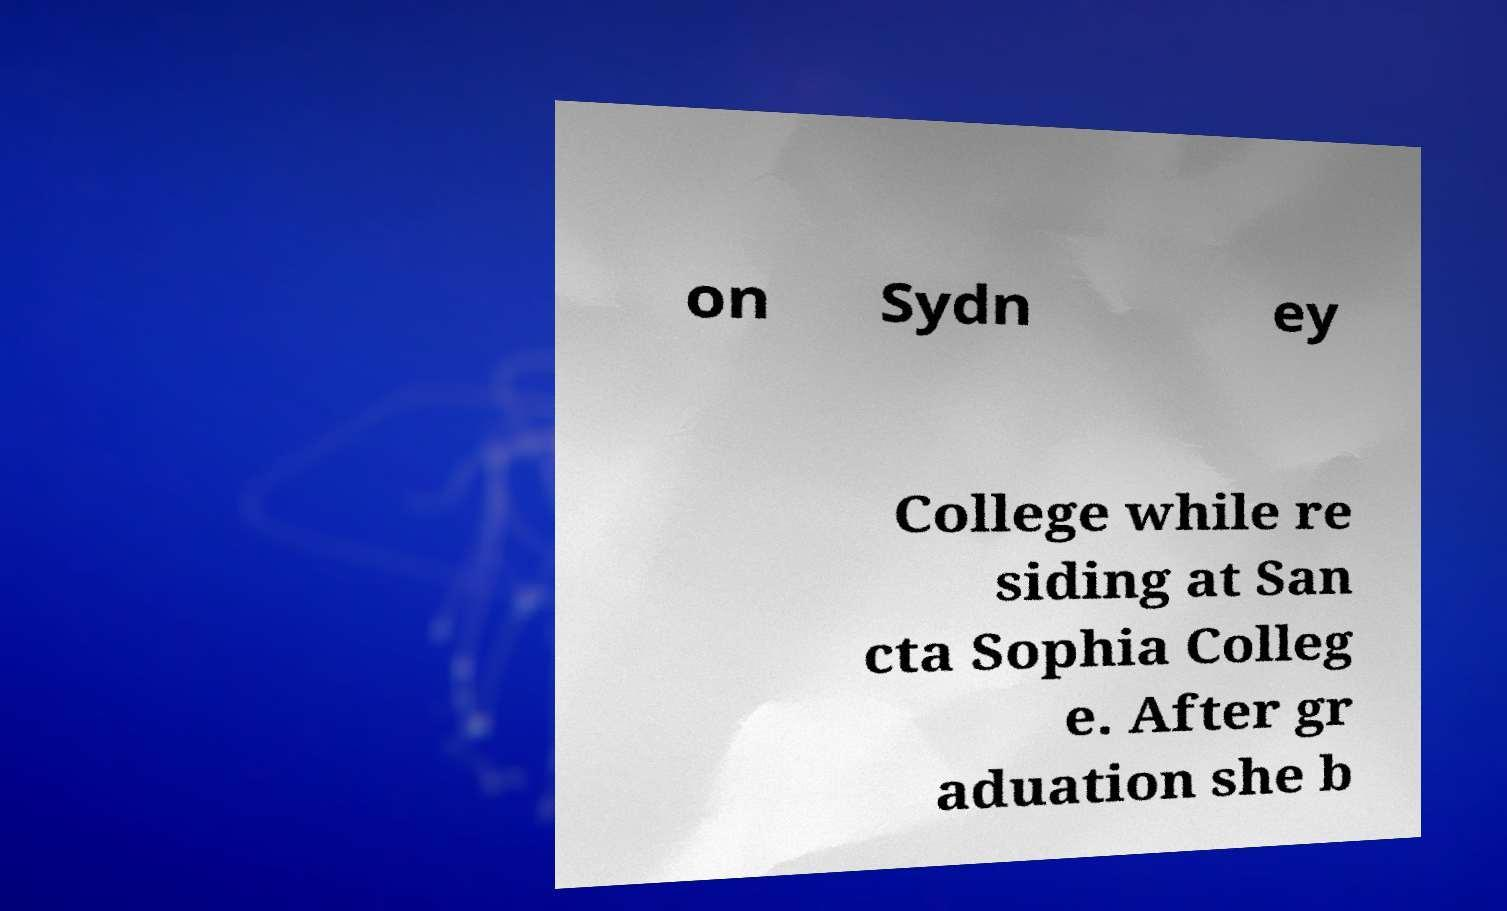Please read and relay the text visible in this image. What does it say? on Sydn ey College while re siding at San cta Sophia Colleg e. After gr aduation she b 